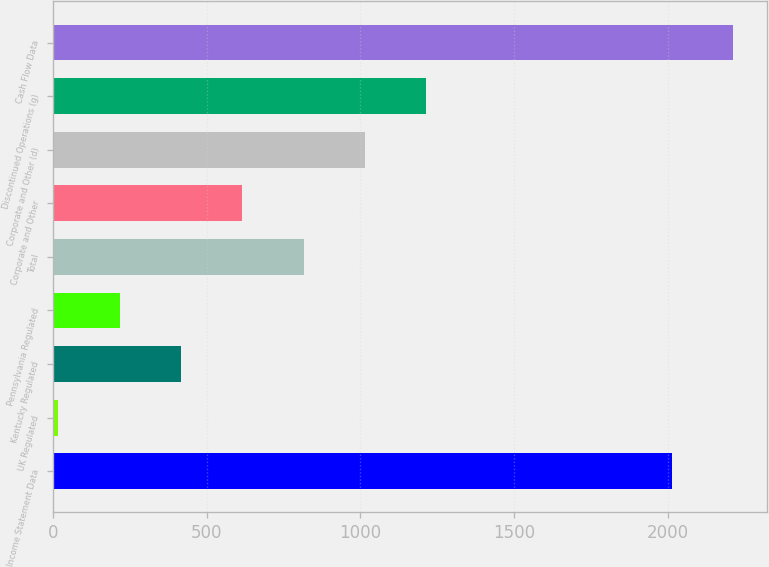<chart> <loc_0><loc_0><loc_500><loc_500><bar_chart><fcel>Income Statement Data<fcel>UK Regulated<fcel>Kentucky Regulated<fcel>Pennsylvania Regulated<fcel>Total<fcel>Corporate and Other<fcel>Corporate and Other (d)<fcel>Discontinued Operations (g)<fcel>Cash Flow Data<nl><fcel>2014<fcel>17<fcel>416.4<fcel>216.7<fcel>815.8<fcel>616.1<fcel>1015.5<fcel>1215.2<fcel>2213.7<nl></chart> 